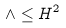<formula> <loc_0><loc_0><loc_500><loc_500>\wedge \leq H ^ { 2 }</formula> 